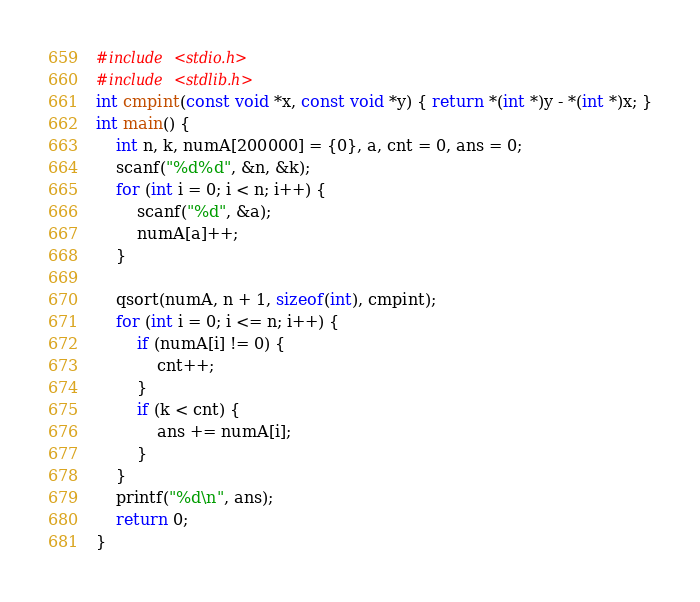<code> <loc_0><loc_0><loc_500><loc_500><_C_>#include <stdio.h>
#include <stdlib.h>
int cmpint(const void *x, const void *y) { return *(int *)y - *(int *)x; }
int main() {
	int n, k, numA[200000] = {0}, a, cnt = 0, ans = 0;
	scanf("%d%d", &n, &k);
	for (int i = 0; i < n; i++) {
		scanf("%d", &a);
		numA[a]++;
	}

	qsort(numA, n + 1, sizeof(int), cmpint);
	for (int i = 0; i <= n; i++) {
		if (numA[i] != 0) {
			cnt++;
		}
		if (k < cnt) {
			ans += numA[i];
		}
	}
	printf("%d\n", ans);
	return 0;
}</code> 